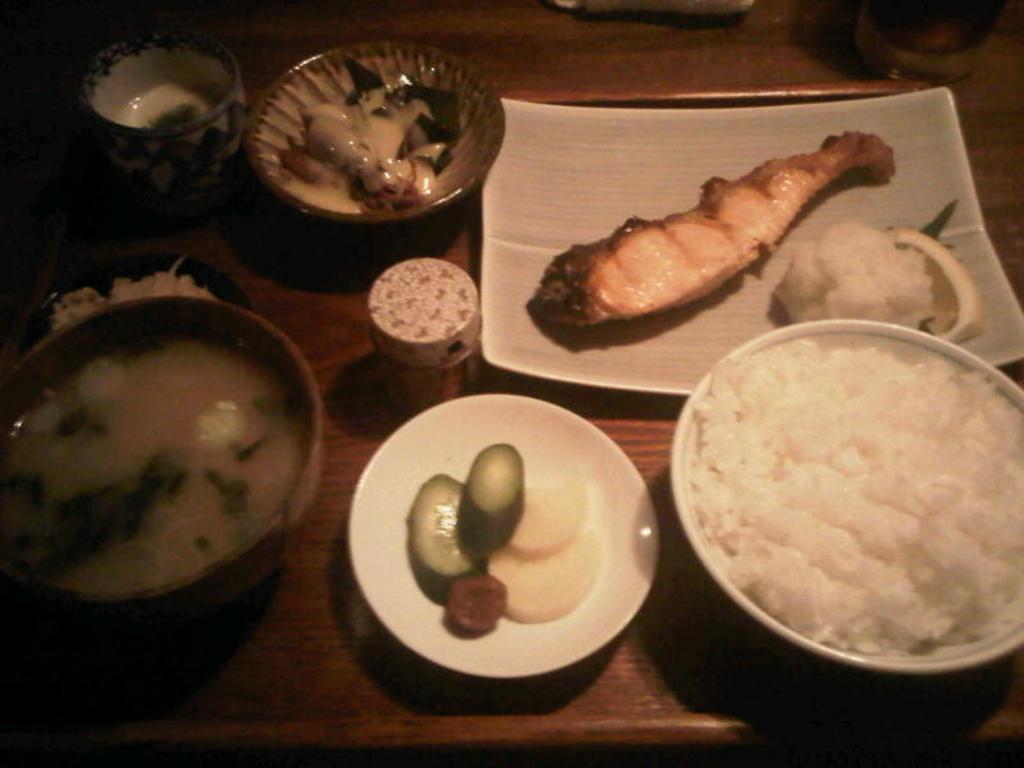Can you describe this image briefly? In this picture I can observe some food places in the plates and bowls. These plates are placed on the table. 